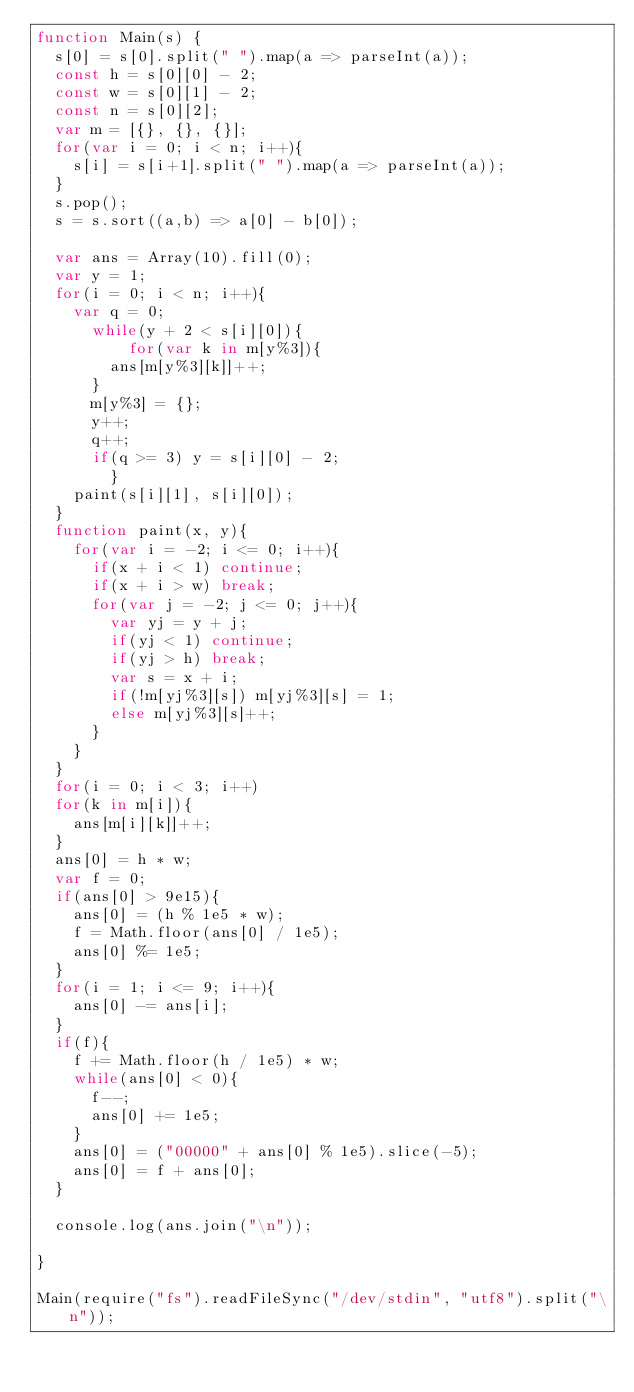<code> <loc_0><loc_0><loc_500><loc_500><_JavaScript_>function Main(s) {
	s[0] = s[0].split(" ").map(a => parseInt(a));
	const h = s[0][0] - 2;
	const w = s[0][1] - 2;
	const n = s[0][2];
	var m = [{}, {}, {}];
	for(var i = 0; i < n; i++){
		s[i] = s[i+1].split(" ").map(a => parseInt(a));
	}
	s.pop();
	s = s.sort((a,b) => a[0] - b[0]);

	var ans = Array(10).fill(0);
	var y = 1;
	for(i = 0; i < n; i++){
		var q = 0;
    	while(y + 2 < s[i][0]){
        	for(var k in m[y%3]){
				ans[m[y%3][k]]++;
			}
			m[y%3] = {};
			y++;
			q++;
			if(q >= 3) y = s[i][0] - 2;
        }
		paint(s[i][1], s[i][0]);
	}
	function paint(x, y){
		for(var i = -2; i <= 0; i++){
			if(x + i < 1) continue;
			if(x + i > w) break;
			for(var j = -2; j <= 0; j++){
				var yj = y + j;
				if(yj < 1) continue;
				if(yj > h) break;
				var s = x + i;
				if(!m[yj%3][s]) m[yj%3][s] = 1;
				else m[yj%3][s]++;
			}
		}
	}
	for(i = 0; i < 3; i++)
	for(k in m[i]){
		ans[m[i][k]]++;
	}
	ans[0] = h * w;
	var f = 0;
	if(ans[0] > 9e15){
		ans[0] = (h % 1e5 * w);
		f = Math.floor(ans[0] / 1e5);
		ans[0] %= 1e5;
	}
	for(i = 1; i <= 9; i++){
		ans[0] -= ans[i];
	}
	if(f){
		f += Math.floor(h / 1e5) * w;
		while(ans[0] < 0){
			f--;
			ans[0] += 1e5;
		}
		ans[0] = ("00000" + ans[0] % 1e5).slice(-5);
		ans[0] = f + ans[0];
	}

	console.log(ans.join("\n"));
	
}

Main(require("fs").readFileSync("/dev/stdin", "utf8").split("\n"));</code> 